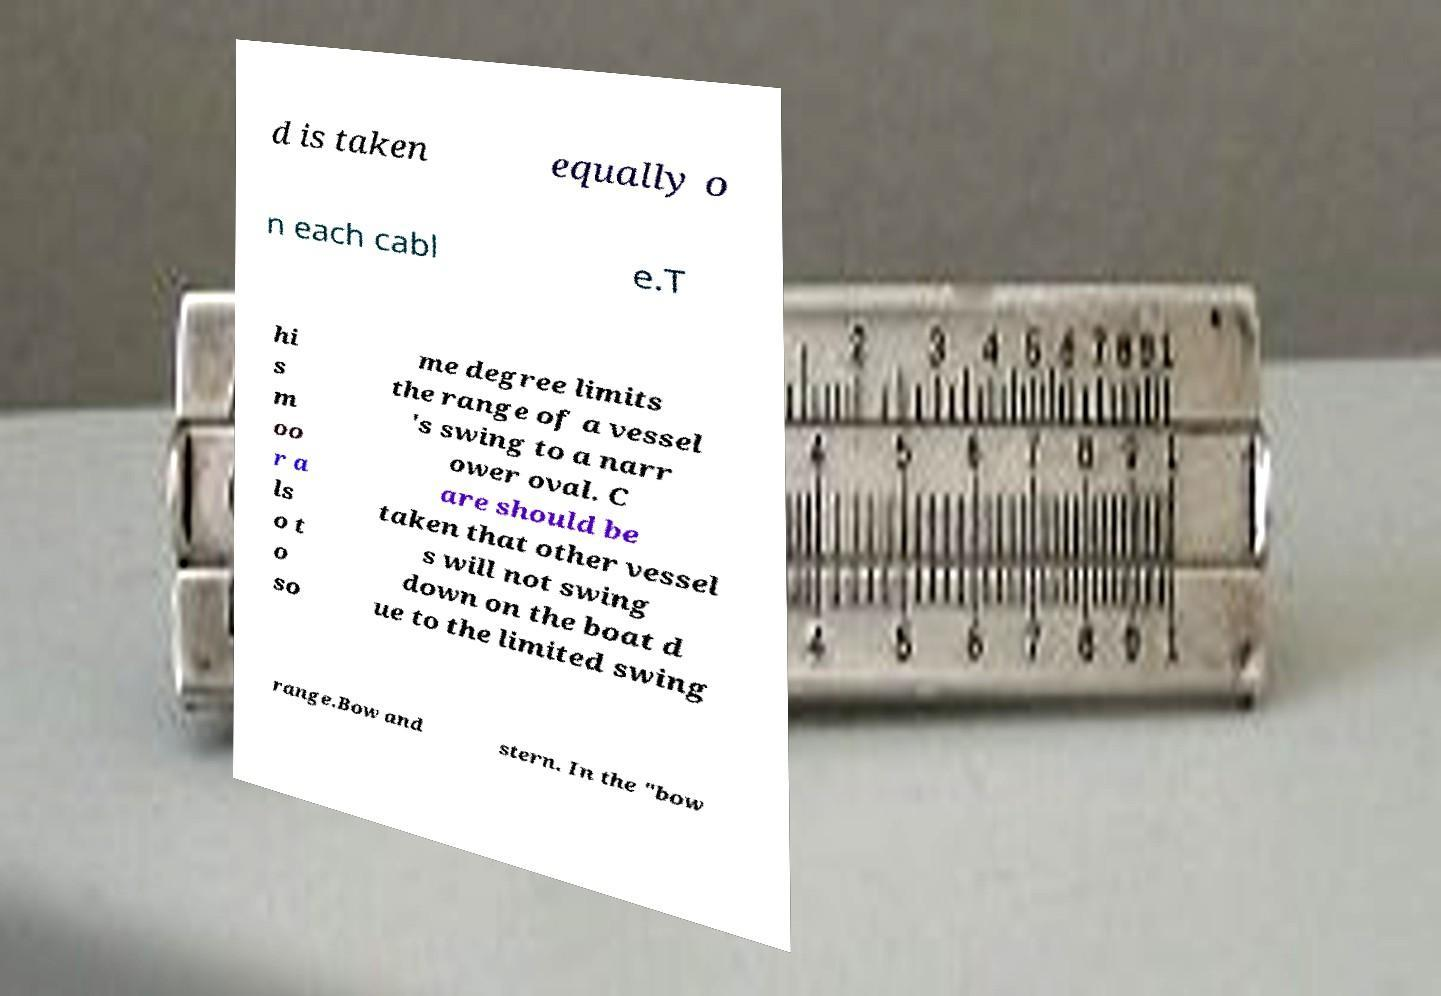For documentation purposes, I need the text within this image transcribed. Could you provide that? d is taken equally o n each cabl e.T hi s m oo r a ls o t o so me degree limits the range of a vessel 's swing to a narr ower oval. C are should be taken that other vessel s will not swing down on the boat d ue to the limited swing range.Bow and stern. In the "bow 